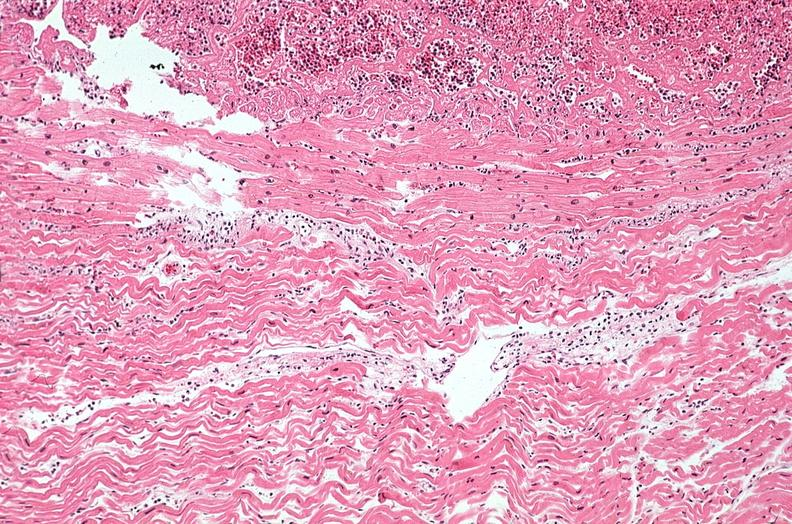what is present?
Answer the question using a single word or phrase. Cardiovascular 